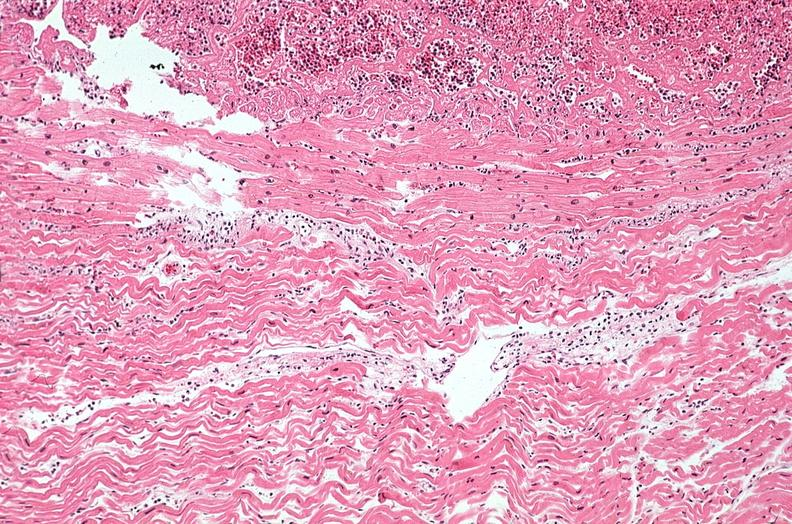what is present?
Answer the question using a single word or phrase. Cardiovascular 